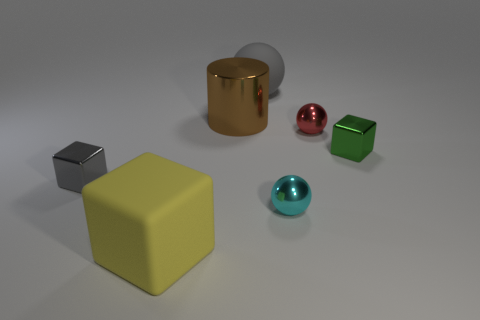Add 1 big brown metallic cylinders. How many objects exist? 8 Subtract all cylinders. How many objects are left? 6 Add 1 yellow things. How many yellow things are left? 2 Add 7 large red rubber objects. How many large red rubber objects exist? 7 Subtract 0 purple spheres. How many objects are left? 7 Subtract all brown cylinders. Subtract all small green things. How many objects are left? 5 